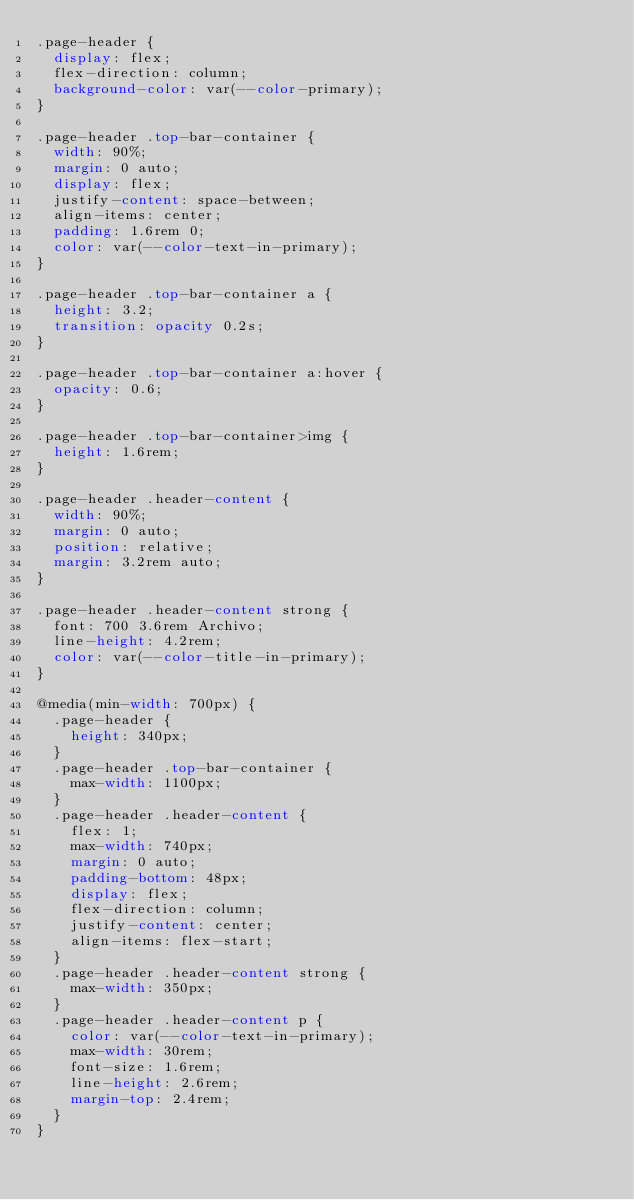<code> <loc_0><loc_0><loc_500><loc_500><_CSS_>.page-header {
  display: flex;
  flex-direction: column;
  background-color: var(--color-primary);
}

.page-header .top-bar-container {
  width: 90%;
  margin: 0 auto;
  display: flex;
  justify-content: space-between;
  align-items: center;
  padding: 1.6rem 0;
  color: var(--color-text-in-primary);
}

.page-header .top-bar-container a {
  height: 3.2;
  transition: opacity 0.2s;
}

.page-header .top-bar-container a:hover {
  opacity: 0.6;
}

.page-header .top-bar-container>img {
  height: 1.6rem;
}

.page-header .header-content {
  width: 90%;
  margin: 0 auto;
  position: relative;
  margin: 3.2rem auto;
}

.page-header .header-content strong {
  font: 700 3.6rem Archivo;
  line-height: 4.2rem;
  color: var(--color-title-in-primary);
}

@media(min-width: 700px) {
  .page-header {
    height: 340px;
  }
  .page-header .top-bar-container {
    max-width: 1100px;
  }
  .page-header .header-content {
    flex: 1;
    max-width: 740px;
    margin: 0 auto;
    padding-bottom: 48px;
    display: flex;
    flex-direction: column;
    justify-content: center;
    align-items: flex-start;
  }
  .page-header .header-content strong {
    max-width: 350px;
  }
  .page-header .header-content p {
    color: var(--color-text-in-primary);
    max-width: 30rem;
    font-size: 1.6rem;
    line-height: 2.6rem;
    margin-top: 2.4rem;
  }
}</code> 